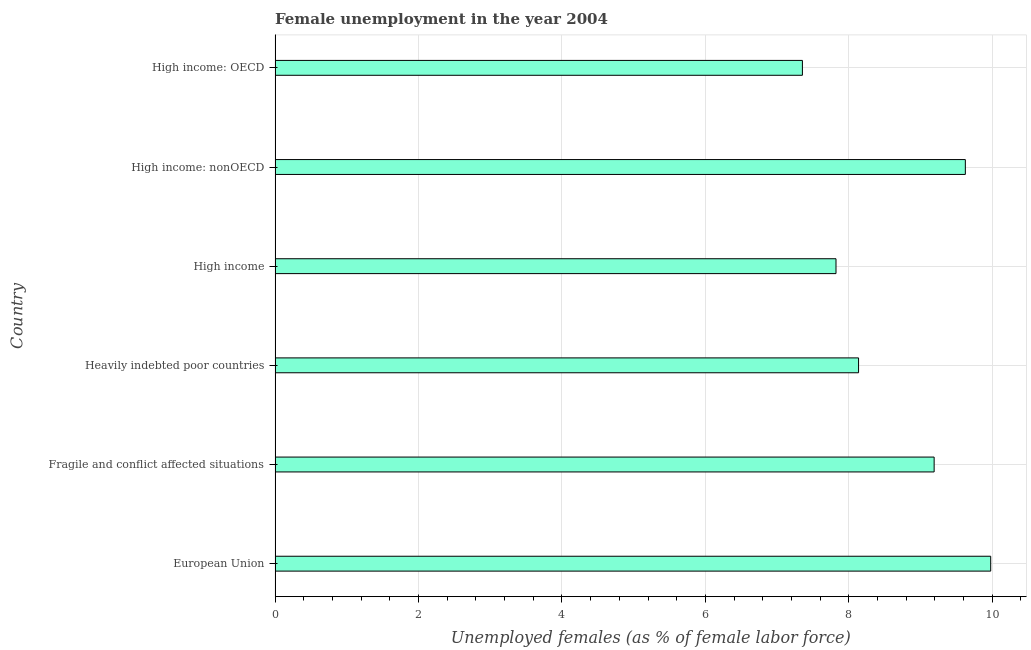Does the graph contain any zero values?
Make the answer very short. No. What is the title of the graph?
Make the answer very short. Female unemployment in the year 2004. What is the label or title of the X-axis?
Offer a terse response. Unemployed females (as % of female labor force). What is the label or title of the Y-axis?
Your response must be concise. Country. What is the unemployed females population in High income: nonOECD?
Ensure brevity in your answer.  9.62. Across all countries, what is the maximum unemployed females population?
Offer a terse response. 9.98. Across all countries, what is the minimum unemployed females population?
Your answer should be compact. 7.35. In which country was the unemployed females population minimum?
Ensure brevity in your answer.  High income: OECD. What is the sum of the unemployed females population?
Your answer should be very brief. 52.1. What is the difference between the unemployed females population in Heavily indebted poor countries and High income: nonOECD?
Give a very brief answer. -1.49. What is the average unemployed females population per country?
Make the answer very short. 8.68. What is the median unemployed females population?
Ensure brevity in your answer.  8.66. In how many countries, is the unemployed females population greater than 1.2 %?
Make the answer very short. 6. What is the ratio of the unemployed females population in European Union to that in High income?
Provide a short and direct response. 1.28. Is the difference between the unemployed females population in Fragile and conflict affected situations and High income: OECD greater than the difference between any two countries?
Your answer should be compact. No. What is the difference between the highest and the second highest unemployed females population?
Keep it short and to the point. 0.35. What is the difference between the highest and the lowest unemployed females population?
Give a very brief answer. 2.63. How many bars are there?
Offer a terse response. 6. Are all the bars in the graph horizontal?
Your answer should be very brief. Yes. What is the difference between two consecutive major ticks on the X-axis?
Ensure brevity in your answer.  2. What is the Unemployed females (as % of female labor force) of European Union?
Provide a short and direct response. 9.98. What is the Unemployed females (as % of female labor force) of Fragile and conflict affected situations?
Offer a terse response. 9.19. What is the Unemployed females (as % of female labor force) of Heavily indebted poor countries?
Provide a succinct answer. 8.14. What is the Unemployed females (as % of female labor force) of High income?
Offer a terse response. 7.82. What is the Unemployed females (as % of female labor force) of High income: nonOECD?
Keep it short and to the point. 9.62. What is the Unemployed females (as % of female labor force) in High income: OECD?
Make the answer very short. 7.35. What is the difference between the Unemployed females (as % of female labor force) in European Union and Fragile and conflict affected situations?
Provide a succinct answer. 0.79. What is the difference between the Unemployed females (as % of female labor force) in European Union and Heavily indebted poor countries?
Provide a short and direct response. 1.84. What is the difference between the Unemployed females (as % of female labor force) in European Union and High income?
Your answer should be compact. 2.16. What is the difference between the Unemployed females (as % of female labor force) in European Union and High income: nonOECD?
Make the answer very short. 0.35. What is the difference between the Unemployed females (as % of female labor force) in European Union and High income: OECD?
Give a very brief answer. 2.63. What is the difference between the Unemployed females (as % of female labor force) in Fragile and conflict affected situations and Heavily indebted poor countries?
Give a very brief answer. 1.05. What is the difference between the Unemployed females (as % of female labor force) in Fragile and conflict affected situations and High income?
Your response must be concise. 1.37. What is the difference between the Unemployed females (as % of female labor force) in Fragile and conflict affected situations and High income: nonOECD?
Your answer should be compact. -0.44. What is the difference between the Unemployed females (as % of female labor force) in Fragile and conflict affected situations and High income: OECD?
Provide a short and direct response. 1.84. What is the difference between the Unemployed females (as % of female labor force) in Heavily indebted poor countries and High income?
Ensure brevity in your answer.  0.31. What is the difference between the Unemployed females (as % of female labor force) in Heavily indebted poor countries and High income: nonOECD?
Keep it short and to the point. -1.49. What is the difference between the Unemployed females (as % of female labor force) in Heavily indebted poor countries and High income: OECD?
Keep it short and to the point. 0.78. What is the difference between the Unemployed females (as % of female labor force) in High income and High income: nonOECD?
Provide a short and direct response. -1.8. What is the difference between the Unemployed females (as % of female labor force) in High income and High income: OECD?
Ensure brevity in your answer.  0.47. What is the difference between the Unemployed females (as % of female labor force) in High income: nonOECD and High income: OECD?
Keep it short and to the point. 2.27. What is the ratio of the Unemployed females (as % of female labor force) in European Union to that in Fragile and conflict affected situations?
Make the answer very short. 1.09. What is the ratio of the Unemployed females (as % of female labor force) in European Union to that in Heavily indebted poor countries?
Your answer should be compact. 1.23. What is the ratio of the Unemployed females (as % of female labor force) in European Union to that in High income?
Give a very brief answer. 1.28. What is the ratio of the Unemployed females (as % of female labor force) in European Union to that in High income: OECD?
Make the answer very short. 1.36. What is the ratio of the Unemployed females (as % of female labor force) in Fragile and conflict affected situations to that in Heavily indebted poor countries?
Your response must be concise. 1.13. What is the ratio of the Unemployed females (as % of female labor force) in Fragile and conflict affected situations to that in High income?
Ensure brevity in your answer.  1.18. What is the ratio of the Unemployed females (as % of female labor force) in Fragile and conflict affected situations to that in High income: nonOECD?
Ensure brevity in your answer.  0.95. What is the ratio of the Unemployed females (as % of female labor force) in Heavily indebted poor countries to that in High income?
Your answer should be very brief. 1.04. What is the ratio of the Unemployed females (as % of female labor force) in Heavily indebted poor countries to that in High income: nonOECD?
Your response must be concise. 0.84. What is the ratio of the Unemployed females (as % of female labor force) in Heavily indebted poor countries to that in High income: OECD?
Your response must be concise. 1.11. What is the ratio of the Unemployed females (as % of female labor force) in High income to that in High income: nonOECD?
Your answer should be compact. 0.81. What is the ratio of the Unemployed females (as % of female labor force) in High income to that in High income: OECD?
Keep it short and to the point. 1.06. What is the ratio of the Unemployed females (as % of female labor force) in High income: nonOECD to that in High income: OECD?
Ensure brevity in your answer.  1.31. 